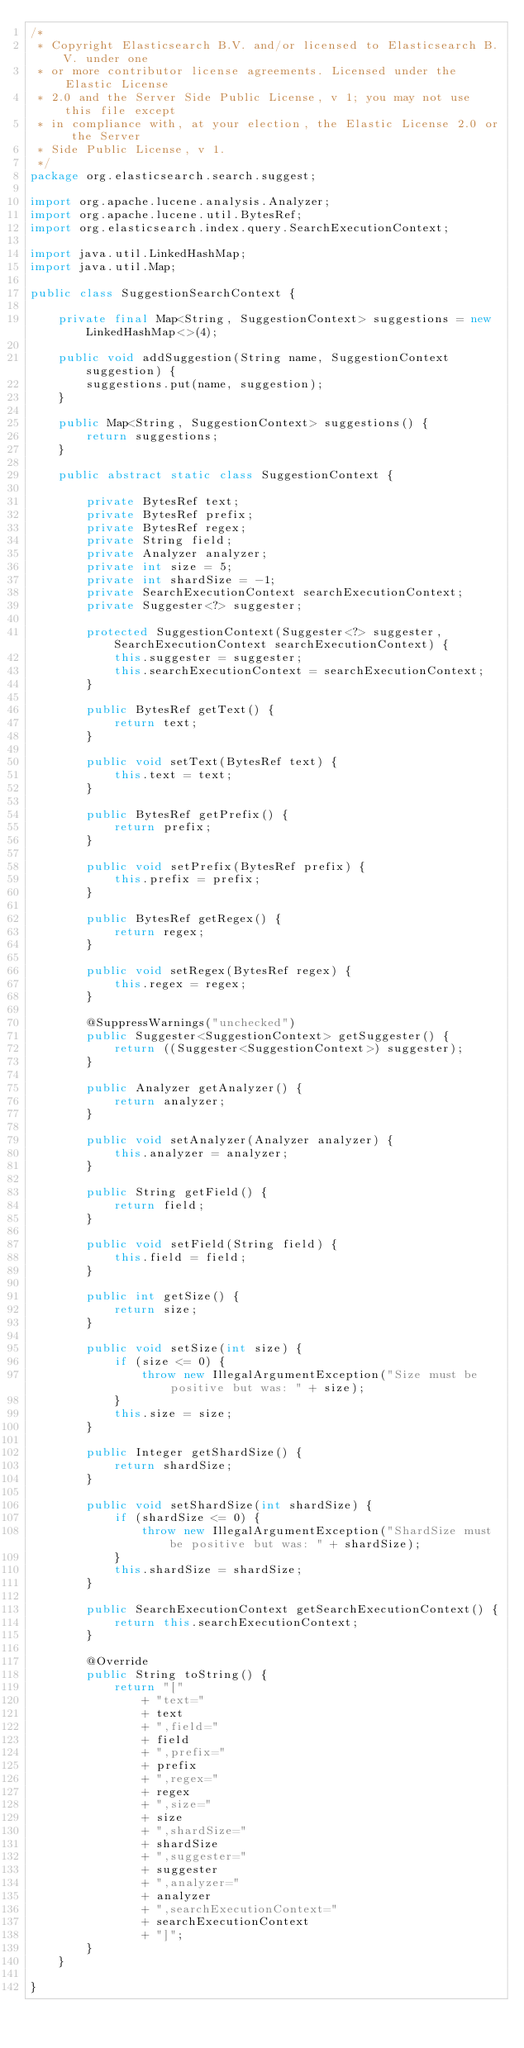<code> <loc_0><loc_0><loc_500><loc_500><_Java_>/*
 * Copyright Elasticsearch B.V. and/or licensed to Elasticsearch B.V. under one
 * or more contributor license agreements. Licensed under the Elastic License
 * 2.0 and the Server Side Public License, v 1; you may not use this file except
 * in compliance with, at your election, the Elastic License 2.0 or the Server
 * Side Public License, v 1.
 */
package org.elasticsearch.search.suggest;

import org.apache.lucene.analysis.Analyzer;
import org.apache.lucene.util.BytesRef;
import org.elasticsearch.index.query.SearchExecutionContext;

import java.util.LinkedHashMap;
import java.util.Map;

public class SuggestionSearchContext {

    private final Map<String, SuggestionContext> suggestions = new LinkedHashMap<>(4);

    public void addSuggestion(String name, SuggestionContext suggestion) {
        suggestions.put(name, suggestion);
    }

    public Map<String, SuggestionContext> suggestions() {
        return suggestions;
    }

    public abstract static class SuggestionContext {

        private BytesRef text;
        private BytesRef prefix;
        private BytesRef regex;
        private String field;
        private Analyzer analyzer;
        private int size = 5;
        private int shardSize = -1;
        private SearchExecutionContext searchExecutionContext;
        private Suggester<?> suggester;

        protected SuggestionContext(Suggester<?> suggester, SearchExecutionContext searchExecutionContext) {
            this.suggester = suggester;
            this.searchExecutionContext = searchExecutionContext;
        }

        public BytesRef getText() {
            return text;
        }

        public void setText(BytesRef text) {
            this.text = text;
        }

        public BytesRef getPrefix() {
            return prefix;
        }

        public void setPrefix(BytesRef prefix) {
            this.prefix = prefix;
        }

        public BytesRef getRegex() {
            return regex;
        }

        public void setRegex(BytesRef regex) {
            this.regex = regex;
        }

        @SuppressWarnings("unchecked")
        public Suggester<SuggestionContext> getSuggester() {
            return ((Suggester<SuggestionContext>) suggester);
        }

        public Analyzer getAnalyzer() {
            return analyzer;
        }

        public void setAnalyzer(Analyzer analyzer) {
            this.analyzer = analyzer;
        }

        public String getField() {
            return field;
        }

        public void setField(String field) {
            this.field = field;
        }

        public int getSize() {
            return size;
        }

        public void setSize(int size) {
            if (size <= 0) {
                throw new IllegalArgumentException("Size must be positive but was: " + size);
            }
            this.size = size;
        }

        public Integer getShardSize() {
            return shardSize;
        }

        public void setShardSize(int shardSize) {
            if (shardSize <= 0) {
                throw new IllegalArgumentException("ShardSize must be positive but was: " + shardSize);
            }
            this.shardSize = shardSize;
        }

        public SearchExecutionContext getSearchExecutionContext() {
            return this.searchExecutionContext;
        }

        @Override
        public String toString() {
            return "["
                + "text="
                + text
                + ",field="
                + field
                + ",prefix="
                + prefix
                + ",regex="
                + regex
                + ",size="
                + size
                + ",shardSize="
                + shardSize
                + ",suggester="
                + suggester
                + ",analyzer="
                + analyzer
                + ",searchExecutionContext="
                + searchExecutionContext
                + "]";
        }
    }

}
</code> 